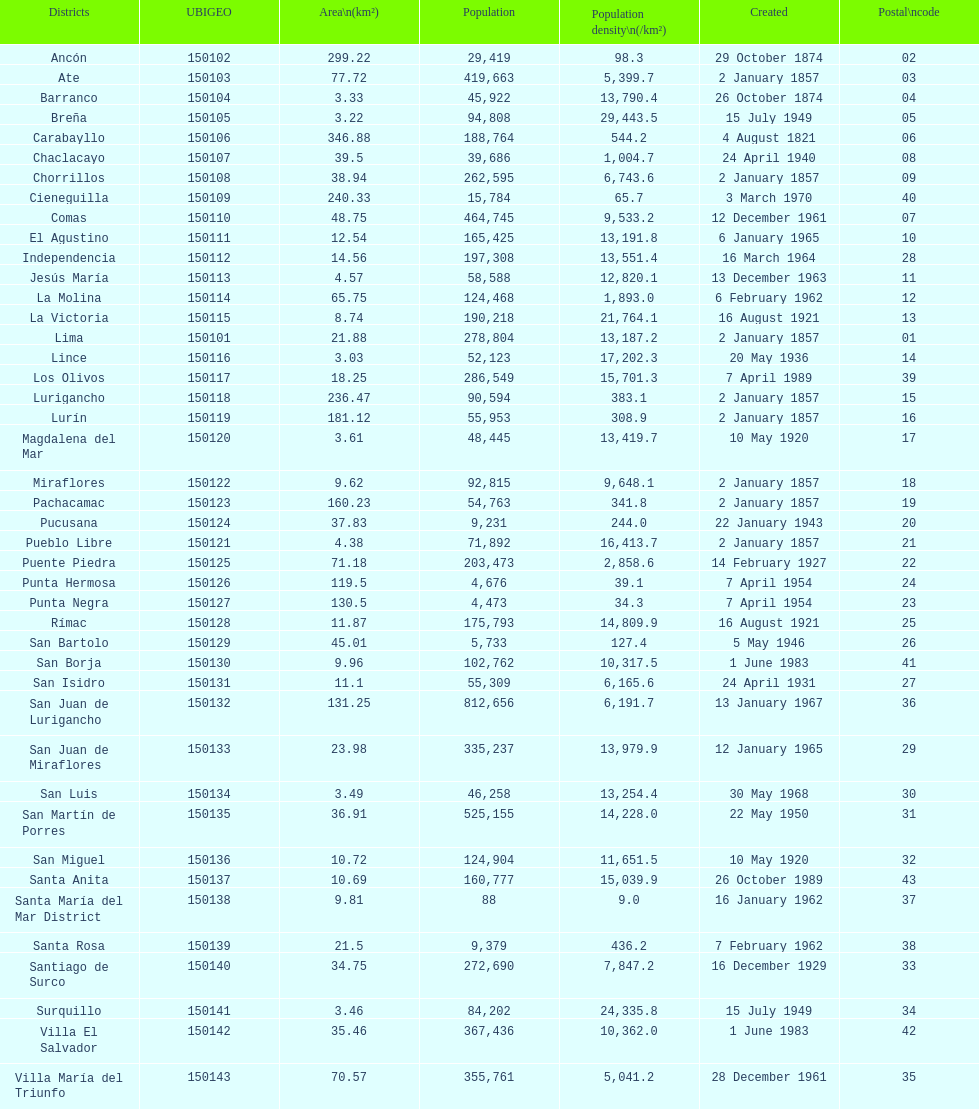Which district in this city has the greatest population? San Juan de Lurigancho. 